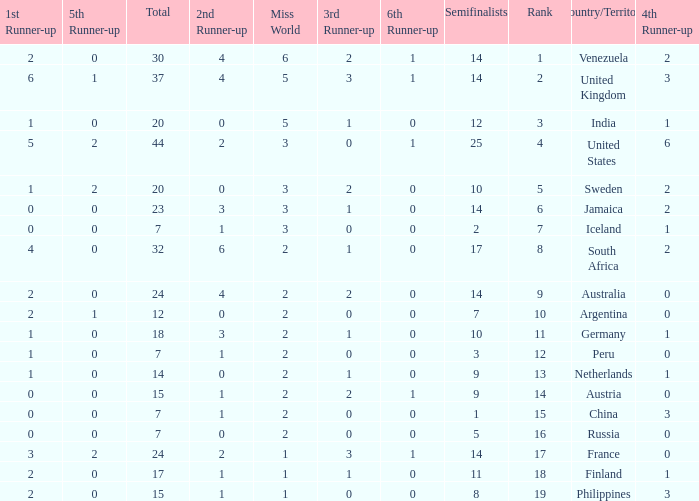What is the United States rank? 1.0. Could you parse the entire table as a dict? {'header': ['1st Runner-up', '5th Runner-up', 'Total', '2nd Runner-up', 'Miss World', '3rd Runner-up', '6th Runner-up', 'Semifinalists', 'Rank', 'Country/Territory', '4th Runner-up'], 'rows': [['2', '0', '30', '4', '6', '2', '1', '14', '1', 'Venezuela', '2'], ['6', '1', '37', '4', '5', '3', '1', '14', '2', 'United Kingdom', '3'], ['1', '0', '20', '0', '5', '1', '0', '12', '3', 'India', '1'], ['5', '2', '44', '2', '3', '0', '1', '25', '4', 'United States', '6'], ['1', '2', '20', '0', '3', '2', '0', '10', '5', 'Sweden', '2'], ['0', '0', '23', '3', '3', '1', '0', '14', '6', 'Jamaica', '2'], ['0', '0', '7', '1', '3', '0', '0', '2', '7', 'Iceland', '1'], ['4', '0', '32', '6', '2', '1', '0', '17', '8', 'South Africa', '2'], ['2', '0', '24', '4', '2', '2', '0', '14', '9', 'Australia', '0'], ['2', '1', '12', '0', '2', '0', '0', '7', '10', 'Argentina', '0'], ['1', '0', '18', '3', '2', '1', '0', '10', '11', 'Germany', '1'], ['1', '0', '7', '1', '2', '0', '0', '3', '12', 'Peru', '0'], ['1', '0', '14', '0', '2', '1', '0', '9', '13', 'Netherlands', '1'], ['0', '0', '15', '1', '2', '2', '1', '9', '14', 'Austria', '0'], ['0', '0', '7', '1', '2', '0', '0', '1', '15', 'China', '3'], ['0', '0', '7', '0', '2', '0', '0', '5', '16', 'Russia', '0'], ['3', '2', '24', '2', '1', '3', '1', '14', '17', 'France', '0'], ['2', '0', '17', '1', '1', '1', '0', '11', '18', 'Finland', '1'], ['2', '0', '15', '1', '1', '0', '0', '8', '19', 'Philippines', '3']]} 